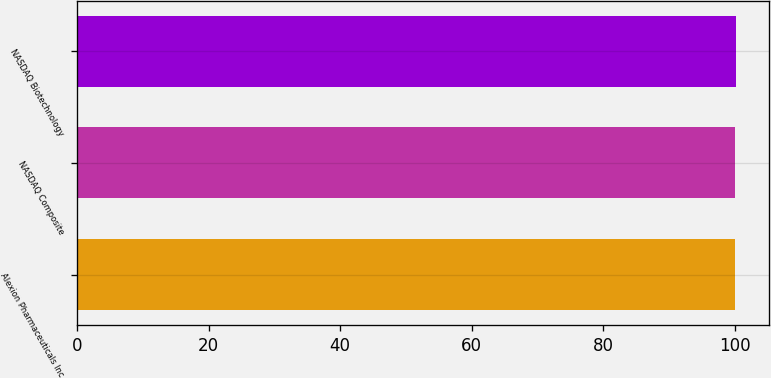Convert chart to OTSL. <chart><loc_0><loc_0><loc_500><loc_500><bar_chart><fcel>Alexion Pharmaceuticals Inc<fcel>NASDAQ Composite<fcel>NASDAQ Biotechnology<nl><fcel>100<fcel>100.1<fcel>100.2<nl></chart> 